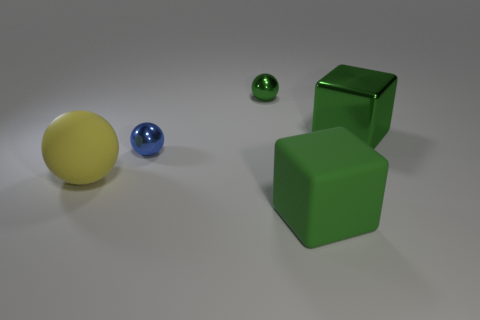Subtract all metallic balls. How many balls are left? 1 Add 3 big yellow blocks. How many objects exist? 8 Subtract all cyan balls. Subtract all yellow cubes. How many balls are left? 3 Subtract all blocks. How many objects are left? 3 Subtract all red rubber blocks. Subtract all small shiny things. How many objects are left? 3 Add 2 blue shiny balls. How many blue shiny balls are left? 3 Add 1 green rubber objects. How many green rubber objects exist? 2 Subtract 0 yellow blocks. How many objects are left? 5 